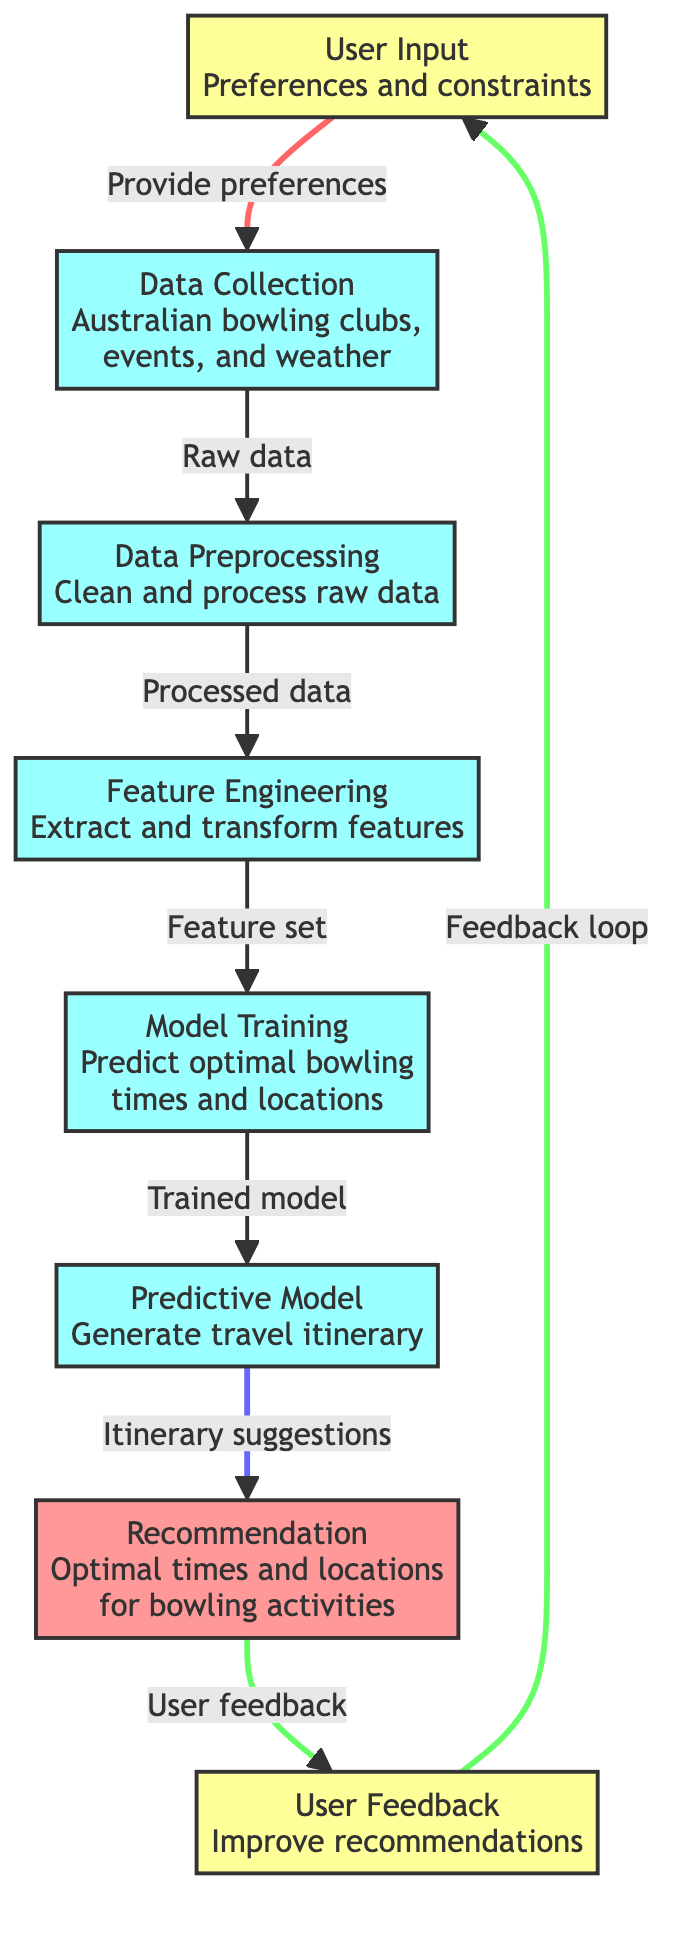What is the first step in the process? The diagram clearly indicates that the first step is "User Input" which involves gathering preferences and constraints from the user.
Answer: User Input How many main processes are there in the diagram? By counting the distinct processes depicted, there are four main processes: data collection, data preprocessing, feature engineering, and model training.
Answer: Four What is the output of the predictive model? The diagram specifies that the output of the predictive model is "Itinerary suggestions."
Answer: Itinerary suggestions What connects user feedback to user input? The diagram illustrates a feedback loop connecting "User Feedback" to "User Input," indicating that user feedback influences future input preferences.
Answer: Feedback loop Which node receives raw data? The flow from "Data Collection" indicates that it is the node receiving raw data collected from various sources related to bowling clubs, events, and weather in Australia.
Answer: Data Preprocessing What is the relationship between feature engineering and model training? The flow shows that feature engineering produces a "Feature set" that is then used as input for model training, suggesting a sequential dependency.
Answer: Sequential dependency What is the function of data preprocessing? The diagram details that data preprocessing is responsible for cleaning and processing raw data, indicating its role in preparing data for further analysis.
Answer: Clean and process raw data How does user feedback improve recommendations? The diagram demonstrates that user feedback is sent back to user input, meaning it impacts the way the system gathers and adjusts preferences for future recommendations.
Answer: Impacts preferences What type of data does the "Data Collection" node gather? The diagram indicates that the data collected includes information about "Australian bowling clubs, events, and weather," which are essential for planning.
Answer: Australian bowling clubs, events, and weather 